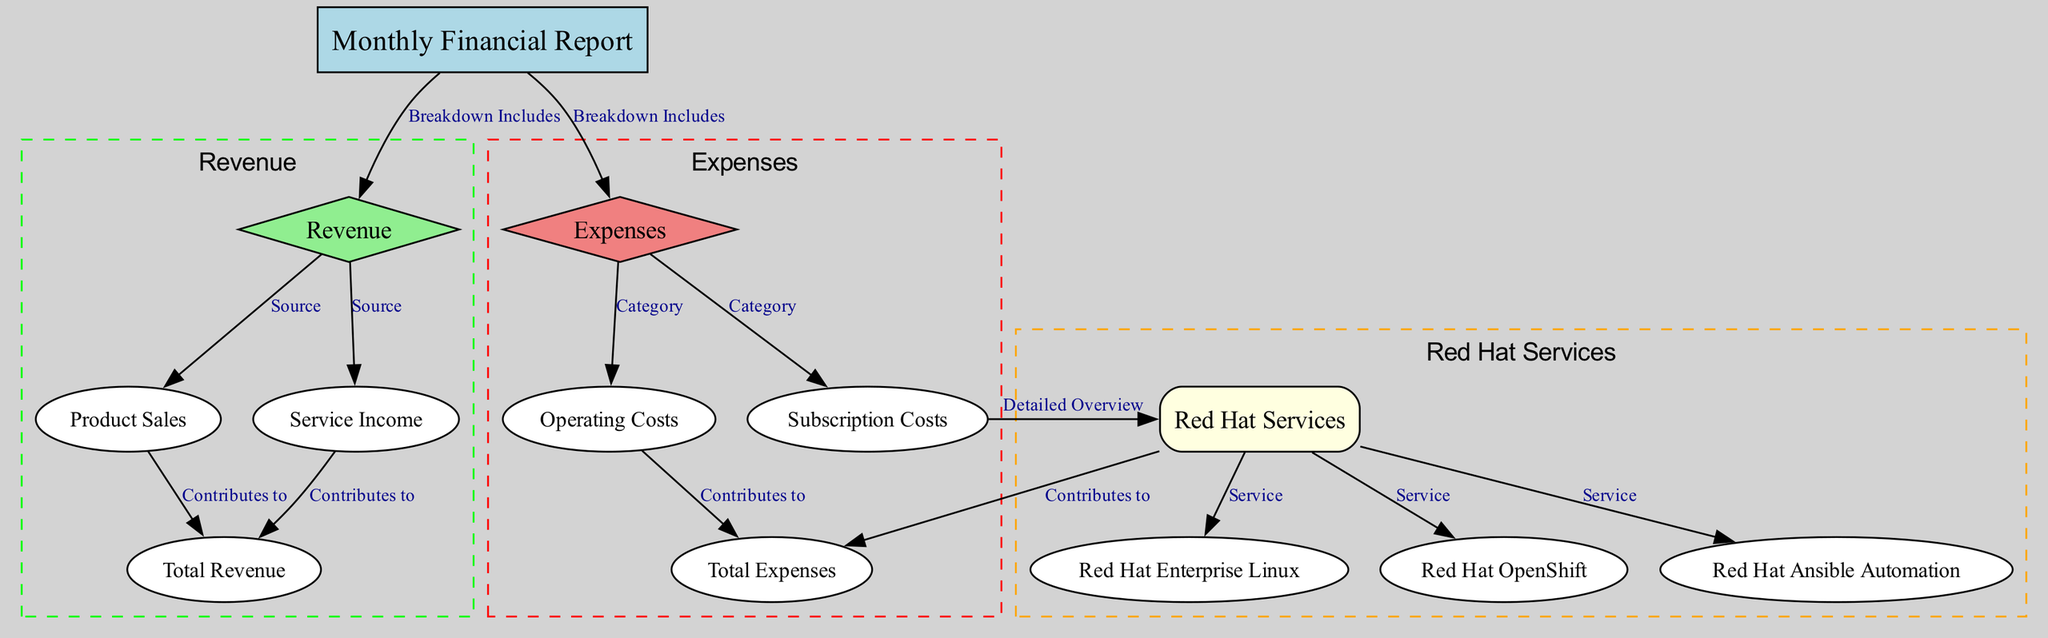What are the sources of revenue? The diagram lists two nodes under the Revenue category: Product Sales and Service Income. Therefore, the sources of revenue are both of these categories.
Answer: Product Sales, Service Income How many nodes are related to Red Hat Services? There are four nodes related to Red Hat Services, which include Red Hat Services itself, Red Hat Enterprise Linux, Red Hat OpenShift, and Red Hat Ansible Automation.
Answer: Four What ultimately contributes to the total expenses? The Total Expenses node receives contributions from Operating Costs and Subscription Costs. Operating Costs and Subscription Costs both link to Total Expenses, thus both contribute.
Answer: Operating Costs, Subscription Costs What is the overall structure of the financial report? The overall structure consists of two major components: Revenue and Expenses, each of which further breaks down into specific sources or categories.
Answer: Revenue and Expenses Which service under Red Hat Services contributes to the expenses? The diagram indicates that Red Hat Services directly contributes to the Total Expenses node. All three services listed (Red Hat Enterprise Linux, Red Hat OpenShift, and Red Hat Ansible Automation) are services within the Red Hat Services category, which also links to Expenses.
Answer: Red Hat Services How does Product Sales contribute to Total Revenue? Product Sales is explicitly shown to contribute to Total Revenue. Following the arrow in the diagram, it can be traced directly from the Product Sales node to the Total Revenue node.
Answer: Contributes directly What is the relationship between Operating Costs and Total Expenses? The relationship is that Operating Costs contribute to Total Expenses. This is indicated by a direct connection from Operating Costs to Total Expenses in the diagram.
Answer: Contributes to Which nodes are categorized as Revenue? The nodes categorized as Revenue are Revenue itself, Product Sales, Service Income, and Total Revenue. These nodes are grouped under the Revenue cluster in the diagram.
Answer: Revenue, Product Sales, Service Income, Total Revenue How many types of Red Hat Services are detailed in the report? The report details three specific types of Red Hat Services: Red Hat Enterprise Linux, Red Hat OpenShift, and Red Hat Ansible Automation.
Answer: Three 